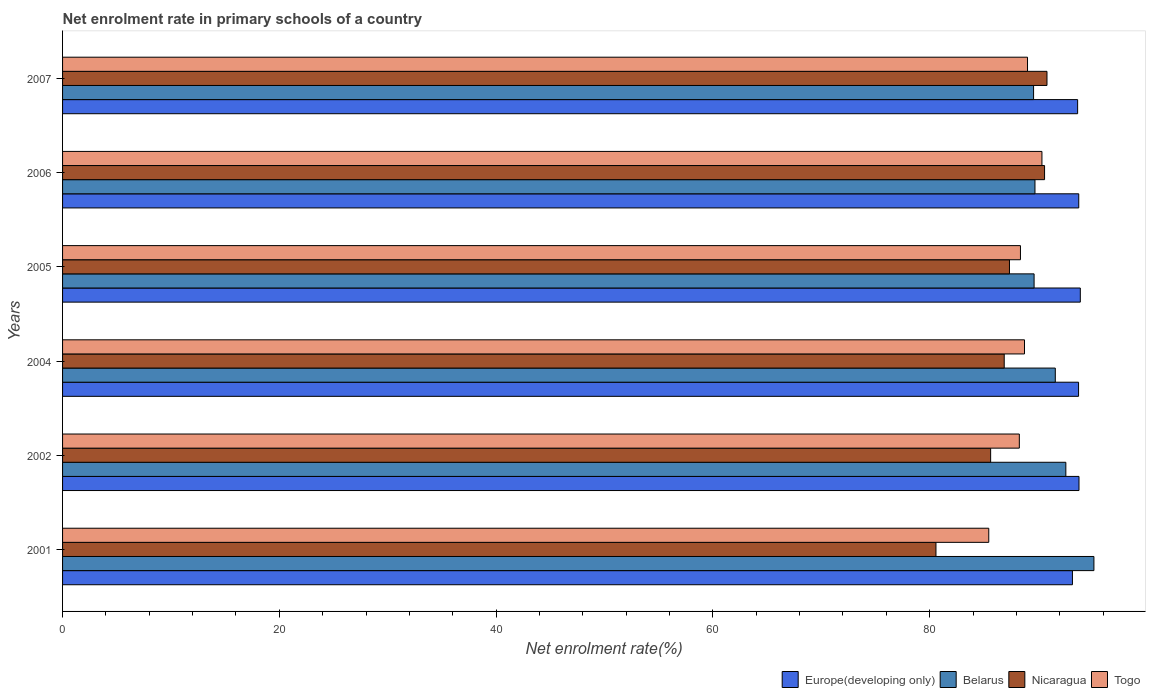How many different coloured bars are there?
Your answer should be very brief. 4. How many groups of bars are there?
Provide a succinct answer. 6. Are the number of bars on each tick of the Y-axis equal?
Your answer should be very brief. Yes. In how many cases, is the number of bars for a given year not equal to the number of legend labels?
Provide a short and direct response. 0. What is the net enrolment rate in primary schools in Belarus in 2005?
Offer a very short reply. 89.64. Across all years, what is the maximum net enrolment rate in primary schools in Belarus?
Provide a succinct answer. 95.16. Across all years, what is the minimum net enrolment rate in primary schools in Belarus?
Give a very brief answer. 89.59. In which year was the net enrolment rate in primary schools in Europe(developing only) maximum?
Offer a terse response. 2005. In which year was the net enrolment rate in primary schools in Togo minimum?
Your response must be concise. 2001. What is the total net enrolment rate in primary schools in Europe(developing only) in the graph?
Your answer should be very brief. 562.01. What is the difference between the net enrolment rate in primary schools in Nicaragua in 2002 and that in 2004?
Your answer should be very brief. -1.25. What is the difference between the net enrolment rate in primary schools in Togo in 2005 and the net enrolment rate in primary schools in Belarus in 2007?
Your answer should be very brief. -1.21. What is the average net enrolment rate in primary schools in Togo per year?
Make the answer very short. 88.38. In the year 2007, what is the difference between the net enrolment rate in primary schools in Europe(developing only) and net enrolment rate in primary schools in Belarus?
Provide a succinct answer. 4.06. What is the ratio of the net enrolment rate in primary schools in Nicaragua in 2005 to that in 2007?
Provide a succinct answer. 0.96. Is the difference between the net enrolment rate in primary schools in Europe(developing only) in 2004 and 2007 greater than the difference between the net enrolment rate in primary schools in Belarus in 2004 and 2007?
Keep it short and to the point. No. What is the difference between the highest and the second highest net enrolment rate in primary schools in Nicaragua?
Give a very brief answer. 0.22. What is the difference between the highest and the lowest net enrolment rate in primary schools in Europe(developing only)?
Ensure brevity in your answer.  0.73. What does the 4th bar from the top in 2001 represents?
Your answer should be compact. Europe(developing only). What does the 3rd bar from the bottom in 2005 represents?
Ensure brevity in your answer.  Nicaragua. What is the difference between two consecutive major ticks on the X-axis?
Give a very brief answer. 20. Does the graph contain any zero values?
Make the answer very short. No. What is the title of the graph?
Your response must be concise. Net enrolment rate in primary schools of a country. What is the label or title of the X-axis?
Offer a very short reply. Net enrolment rate(%). What is the Net enrolment rate(%) of Europe(developing only) in 2001?
Ensure brevity in your answer.  93.18. What is the Net enrolment rate(%) in Belarus in 2001?
Ensure brevity in your answer.  95.16. What is the Net enrolment rate(%) of Nicaragua in 2001?
Provide a short and direct response. 80.58. What is the Net enrolment rate(%) of Togo in 2001?
Your answer should be very brief. 85.45. What is the Net enrolment rate(%) in Europe(developing only) in 2002?
Offer a very short reply. 93.78. What is the Net enrolment rate(%) in Belarus in 2002?
Your answer should be compact. 92.57. What is the Net enrolment rate(%) in Nicaragua in 2002?
Your answer should be very brief. 85.63. What is the Net enrolment rate(%) of Togo in 2002?
Offer a very short reply. 88.28. What is the Net enrolment rate(%) in Europe(developing only) in 2004?
Make the answer very short. 93.74. What is the Net enrolment rate(%) of Belarus in 2004?
Keep it short and to the point. 91.59. What is the Net enrolment rate(%) in Nicaragua in 2004?
Give a very brief answer. 86.88. What is the Net enrolment rate(%) in Togo in 2004?
Offer a very short reply. 88.75. What is the Net enrolment rate(%) of Europe(developing only) in 2005?
Your answer should be compact. 93.9. What is the Net enrolment rate(%) of Belarus in 2005?
Offer a terse response. 89.64. What is the Net enrolment rate(%) of Nicaragua in 2005?
Keep it short and to the point. 87.37. What is the Net enrolment rate(%) in Togo in 2005?
Offer a very short reply. 88.38. What is the Net enrolment rate(%) of Europe(developing only) in 2006?
Your answer should be very brief. 93.76. What is the Net enrolment rate(%) in Belarus in 2006?
Provide a succinct answer. 89.72. What is the Net enrolment rate(%) in Nicaragua in 2006?
Offer a very short reply. 90.6. What is the Net enrolment rate(%) of Togo in 2006?
Ensure brevity in your answer.  90.36. What is the Net enrolment rate(%) in Europe(developing only) in 2007?
Offer a very short reply. 93.65. What is the Net enrolment rate(%) in Belarus in 2007?
Give a very brief answer. 89.59. What is the Net enrolment rate(%) in Nicaragua in 2007?
Ensure brevity in your answer.  90.83. What is the Net enrolment rate(%) in Togo in 2007?
Offer a terse response. 89.03. Across all years, what is the maximum Net enrolment rate(%) in Europe(developing only)?
Offer a terse response. 93.9. Across all years, what is the maximum Net enrolment rate(%) in Belarus?
Your answer should be very brief. 95.16. Across all years, what is the maximum Net enrolment rate(%) of Nicaragua?
Provide a succinct answer. 90.83. Across all years, what is the maximum Net enrolment rate(%) of Togo?
Provide a short and direct response. 90.36. Across all years, what is the minimum Net enrolment rate(%) of Europe(developing only)?
Make the answer very short. 93.18. Across all years, what is the minimum Net enrolment rate(%) of Belarus?
Your answer should be compact. 89.59. Across all years, what is the minimum Net enrolment rate(%) of Nicaragua?
Give a very brief answer. 80.58. Across all years, what is the minimum Net enrolment rate(%) in Togo?
Your answer should be compact. 85.45. What is the total Net enrolment rate(%) of Europe(developing only) in the graph?
Provide a succinct answer. 562.01. What is the total Net enrolment rate(%) of Belarus in the graph?
Give a very brief answer. 548.26. What is the total Net enrolment rate(%) of Nicaragua in the graph?
Your answer should be very brief. 521.89. What is the total Net enrolment rate(%) in Togo in the graph?
Offer a very short reply. 530.25. What is the difference between the Net enrolment rate(%) in Europe(developing only) in 2001 and that in 2002?
Offer a very short reply. -0.6. What is the difference between the Net enrolment rate(%) in Belarus in 2001 and that in 2002?
Give a very brief answer. 2.59. What is the difference between the Net enrolment rate(%) in Nicaragua in 2001 and that in 2002?
Make the answer very short. -5.04. What is the difference between the Net enrolment rate(%) in Togo in 2001 and that in 2002?
Offer a terse response. -2.82. What is the difference between the Net enrolment rate(%) in Europe(developing only) in 2001 and that in 2004?
Your response must be concise. -0.56. What is the difference between the Net enrolment rate(%) in Belarus in 2001 and that in 2004?
Keep it short and to the point. 3.56. What is the difference between the Net enrolment rate(%) in Nicaragua in 2001 and that in 2004?
Your answer should be compact. -6.3. What is the difference between the Net enrolment rate(%) in Togo in 2001 and that in 2004?
Provide a short and direct response. -3.3. What is the difference between the Net enrolment rate(%) of Europe(developing only) in 2001 and that in 2005?
Keep it short and to the point. -0.73. What is the difference between the Net enrolment rate(%) in Belarus in 2001 and that in 2005?
Your response must be concise. 5.52. What is the difference between the Net enrolment rate(%) in Nicaragua in 2001 and that in 2005?
Make the answer very short. -6.78. What is the difference between the Net enrolment rate(%) of Togo in 2001 and that in 2005?
Provide a short and direct response. -2.92. What is the difference between the Net enrolment rate(%) in Europe(developing only) in 2001 and that in 2006?
Your answer should be compact. -0.58. What is the difference between the Net enrolment rate(%) of Belarus in 2001 and that in 2006?
Your answer should be compact. 5.44. What is the difference between the Net enrolment rate(%) in Nicaragua in 2001 and that in 2006?
Offer a terse response. -10.02. What is the difference between the Net enrolment rate(%) of Togo in 2001 and that in 2006?
Offer a terse response. -4.91. What is the difference between the Net enrolment rate(%) in Europe(developing only) in 2001 and that in 2007?
Your response must be concise. -0.48. What is the difference between the Net enrolment rate(%) of Belarus in 2001 and that in 2007?
Provide a succinct answer. 5.57. What is the difference between the Net enrolment rate(%) of Nicaragua in 2001 and that in 2007?
Make the answer very short. -10.24. What is the difference between the Net enrolment rate(%) of Togo in 2001 and that in 2007?
Keep it short and to the point. -3.58. What is the difference between the Net enrolment rate(%) of Europe(developing only) in 2002 and that in 2004?
Your answer should be very brief. 0.04. What is the difference between the Net enrolment rate(%) in Belarus in 2002 and that in 2004?
Your answer should be compact. 0.97. What is the difference between the Net enrolment rate(%) in Nicaragua in 2002 and that in 2004?
Provide a short and direct response. -1.25. What is the difference between the Net enrolment rate(%) in Togo in 2002 and that in 2004?
Ensure brevity in your answer.  -0.48. What is the difference between the Net enrolment rate(%) in Europe(developing only) in 2002 and that in 2005?
Your answer should be very brief. -0.12. What is the difference between the Net enrolment rate(%) in Belarus in 2002 and that in 2005?
Keep it short and to the point. 2.93. What is the difference between the Net enrolment rate(%) in Nicaragua in 2002 and that in 2005?
Keep it short and to the point. -1.74. What is the difference between the Net enrolment rate(%) of Togo in 2002 and that in 2005?
Ensure brevity in your answer.  -0.1. What is the difference between the Net enrolment rate(%) in Europe(developing only) in 2002 and that in 2006?
Provide a succinct answer. 0.02. What is the difference between the Net enrolment rate(%) in Belarus in 2002 and that in 2006?
Provide a short and direct response. 2.85. What is the difference between the Net enrolment rate(%) of Nicaragua in 2002 and that in 2006?
Ensure brevity in your answer.  -4.98. What is the difference between the Net enrolment rate(%) of Togo in 2002 and that in 2006?
Make the answer very short. -2.08. What is the difference between the Net enrolment rate(%) in Europe(developing only) in 2002 and that in 2007?
Keep it short and to the point. 0.13. What is the difference between the Net enrolment rate(%) of Belarus in 2002 and that in 2007?
Provide a short and direct response. 2.98. What is the difference between the Net enrolment rate(%) of Nicaragua in 2002 and that in 2007?
Provide a short and direct response. -5.2. What is the difference between the Net enrolment rate(%) of Togo in 2002 and that in 2007?
Ensure brevity in your answer.  -0.76. What is the difference between the Net enrolment rate(%) of Europe(developing only) in 2004 and that in 2005?
Offer a very short reply. -0.16. What is the difference between the Net enrolment rate(%) in Belarus in 2004 and that in 2005?
Ensure brevity in your answer.  1.96. What is the difference between the Net enrolment rate(%) in Nicaragua in 2004 and that in 2005?
Your answer should be very brief. -0.48. What is the difference between the Net enrolment rate(%) in Togo in 2004 and that in 2005?
Provide a short and direct response. 0.37. What is the difference between the Net enrolment rate(%) of Europe(developing only) in 2004 and that in 2006?
Keep it short and to the point. -0.02. What is the difference between the Net enrolment rate(%) of Belarus in 2004 and that in 2006?
Your answer should be compact. 1.88. What is the difference between the Net enrolment rate(%) of Nicaragua in 2004 and that in 2006?
Ensure brevity in your answer.  -3.72. What is the difference between the Net enrolment rate(%) of Togo in 2004 and that in 2006?
Your answer should be very brief. -1.61. What is the difference between the Net enrolment rate(%) in Europe(developing only) in 2004 and that in 2007?
Offer a very short reply. 0.09. What is the difference between the Net enrolment rate(%) of Belarus in 2004 and that in 2007?
Keep it short and to the point. 2. What is the difference between the Net enrolment rate(%) in Nicaragua in 2004 and that in 2007?
Your answer should be very brief. -3.95. What is the difference between the Net enrolment rate(%) in Togo in 2004 and that in 2007?
Provide a succinct answer. -0.28. What is the difference between the Net enrolment rate(%) in Europe(developing only) in 2005 and that in 2006?
Provide a succinct answer. 0.15. What is the difference between the Net enrolment rate(%) of Belarus in 2005 and that in 2006?
Provide a succinct answer. -0.08. What is the difference between the Net enrolment rate(%) of Nicaragua in 2005 and that in 2006?
Make the answer very short. -3.24. What is the difference between the Net enrolment rate(%) of Togo in 2005 and that in 2006?
Your answer should be very brief. -1.98. What is the difference between the Net enrolment rate(%) of Europe(developing only) in 2005 and that in 2007?
Offer a terse response. 0.25. What is the difference between the Net enrolment rate(%) of Belarus in 2005 and that in 2007?
Your answer should be compact. 0.05. What is the difference between the Net enrolment rate(%) of Nicaragua in 2005 and that in 2007?
Your answer should be very brief. -3.46. What is the difference between the Net enrolment rate(%) in Togo in 2005 and that in 2007?
Make the answer very short. -0.65. What is the difference between the Net enrolment rate(%) of Europe(developing only) in 2006 and that in 2007?
Ensure brevity in your answer.  0.1. What is the difference between the Net enrolment rate(%) in Belarus in 2006 and that in 2007?
Give a very brief answer. 0.13. What is the difference between the Net enrolment rate(%) of Nicaragua in 2006 and that in 2007?
Your answer should be very brief. -0.22. What is the difference between the Net enrolment rate(%) in Togo in 2006 and that in 2007?
Ensure brevity in your answer.  1.33. What is the difference between the Net enrolment rate(%) of Europe(developing only) in 2001 and the Net enrolment rate(%) of Belarus in 2002?
Offer a very short reply. 0.61. What is the difference between the Net enrolment rate(%) in Europe(developing only) in 2001 and the Net enrolment rate(%) in Nicaragua in 2002?
Your answer should be compact. 7.55. What is the difference between the Net enrolment rate(%) of Europe(developing only) in 2001 and the Net enrolment rate(%) of Togo in 2002?
Offer a terse response. 4.9. What is the difference between the Net enrolment rate(%) in Belarus in 2001 and the Net enrolment rate(%) in Nicaragua in 2002?
Provide a succinct answer. 9.53. What is the difference between the Net enrolment rate(%) in Belarus in 2001 and the Net enrolment rate(%) in Togo in 2002?
Keep it short and to the point. 6.88. What is the difference between the Net enrolment rate(%) of Nicaragua in 2001 and the Net enrolment rate(%) of Togo in 2002?
Give a very brief answer. -7.69. What is the difference between the Net enrolment rate(%) in Europe(developing only) in 2001 and the Net enrolment rate(%) in Belarus in 2004?
Offer a very short reply. 1.58. What is the difference between the Net enrolment rate(%) in Europe(developing only) in 2001 and the Net enrolment rate(%) in Nicaragua in 2004?
Your answer should be very brief. 6.29. What is the difference between the Net enrolment rate(%) of Europe(developing only) in 2001 and the Net enrolment rate(%) of Togo in 2004?
Make the answer very short. 4.42. What is the difference between the Net enrolment rate(%) in Belarus in 2001 and the Net enrolment rate(%) in Nicaragua in 2004?
Keep it short and to the point. 8.28. What is the difference between the Net enrolment rate(%) of Belarus in 2001 and the Net enrolment rate(%) of Togo in 2004?
Your answer should be compact. 6.41. What is the difference between the Net enrolment rate(%) in Nicaragua in 2001 and the Net enrolment rate(%) in Togo in 2004?
Offer a terse response. -8.17. What is the difference between the Net enrolment rate(%) in Europe(developing only) in 2001 and the Net enrolment rate(%) in Belarus in 2005?
Give a very brief answer. 3.54. What is the difference between the Net enrolment rate(%) in Europe(developing only) in 2001 and the Net enrolment rate(%) in Nicaragua in 2005?
Offer a very short reply. 5.81. What is the difference between the Net enrolment rate(%) in Europe(developing only) in 2001 and the Net enrolment rate(%) in Togo in 2005?
Offer a very short reply. 4.8. What is the difference between the Net enrolment rate(%) of Belarus in 2001 and the Net enrolment rate(%) of Nicaragua in 2005?
Give a very brief answer. 7.79. What is the difference between the Net enrolment rate(%) of Belarus in 2001 and the Net enrolment rate(%) of Togo in 2005?
Ensure brevity in your answer.  6.78. What is the difference between the Net enrolment rate(%) in Nicaragua in 2001 and the Net enrolment rate(%) in Togo in 2005?
Keep it short and to the point. -7.79. What is the difference between the Net enrolment rate(%) of Europe(developing only) in 2001 and the Net enrolment rate(%) of Belarus in 2006?
Provide a short and direct response. 3.46. What is the difference between the Net enrolment rate(%) in Europe(developing only) in 2001 and the Net enrolment rate(%) in Nicaragua in 2006?
Make the answer very short. 2.57. What is the difference between the Net enrolment rate(%) of Europe(developing only) in 2001 and the Net enrolment rate(%) of Togo in 2006?
Offer a very short reply. 2.82. What is the difference between the Net enrolment rate(%) of Belarus in 2001 and the Net enrolment rate(%) of Nicaragua in 2006?
Make the answer very short. 4.55. What is the difference between the Net enrolment rate(%) of Belarus in 2001 and the Net enrolment rate(%) of Togo in 2006?
Provide a short and direct response. 4.8. What is the difference between the Net enrolment rate(%) of Nicaragua in 2001 and the Net enrolment rate(%) of Togo in 2006?
Your answer should be compact. -9.78. What is the difference between the Net enrolment rate(%) in Europe(developing only) in 2001 and the Net enrolment rate(%) in Belarus in 2007?
Your answer should be very brief. 3.59. What is the difference between the Net enrolment rate(%) of Europe(developing only) in 2001 and the Net enrolment rate(%) of Nicaragua in 2007?
Your answer should be very brief. 2.35. What is the difference between the Net enrolment rate(%) of Europe(developing only) in 2001 and the Net enrolment rate(%) of Togo in 2007?
Offer a terse response. 4.14. What is the difference between the Net enrolment rate(%) in Belarus in 2001 and the Net enrolment rate(%) in Nicaragua in 2007?
Make the answer very short. 4.33. What is the difference between the Net enrolment rate(%) in Belarus in 2001 and the Net enrolment rate(%) in Togo in 2007?
Make the answer very short. 6.13. What is the difference between the Net enrolment rate(%) in Nicaragua in 2001 and the Net enrolment rate(%) in Togo in 2007?
Your answer should be very brief. -8.45. What is the difference between the Net enrolment rate(%) of Europe(developing only) in 2002 and the Net enrolment rate(%) of Belarus in 2004?
Your response must be concise. 2.19. What is the difference between the Net enrolment rate(%) of Europe(developing only) in 2002 and the Net enrolment rate(%) of Nicaragua in 2004?
Your response must be concise. 6.9. What is the difference between the Net enrolment rate(%) of Europe(developing only) in 2002 and the Net enrolment rate(%) of Togo in 2004?
Your answer should be compact. 5.03. What is the difference between the Net enrolment rate(%) of Belarus in 2002 and the Net enrolment rate(%) of Nicaragua in 2004?
Your response must be concise. 5.69. What is the difference between the Net enrolment rate(%) of Belarus in 2002 and the Net enrolment rate(%) of Togo in 2004?
Your response must be concise. 3.82. What is the difference between the Net enrolment rate(%) in Nicaragua in 2002 and the Net enrolment rate(%) in Togo in 2004?
Ensure brevity in your answer.  -3.12. What is the difference between the Net enrolment rate(%) of Europe(developing only) in 2002 and the Net enrolment rate(%) of Belarus in 2005?
Make the answer very short. 4.14. What is the difference between the Net enrolment rate(%) in Europe(developing only) in 2002 and the Net enrolment rate(%) in Nicaragua in 2005?
Your answer should be very brief. 6.41. What is the difference between the Net enrolment rate(%) of Europe(developing only) in 2002 and the Net enrolment rate(%) of Togo in 2005?
Your answer should be very brief. 5.4. What is the difference between the Net enrolment rate(%) of Belarus in 2002 and the Net enrolment rate(%) of Nicaragua in 2005?
Your answer should be compact. 5.2. What is the difference between the Net enrolment rate(%) of Belarus in 2002 and the Net enrolment rate(%) of Togo in 2005?
Ensure brevity in your answer.  4.19. What is the difference between the Net enrolment rate(%) in Nicaragua in 2002 and the Net enrolment rate(%) in Togo in 2005?
Provide a succinct answer. -2.75. What is the difference between the Net enrolment rate(%) in Europe(developing only) in 2002 and the Net enrolment rate(%) in Belarus in 2006?
Your response must be concise. 4.06. What is the difference between the Net enrolment rate(%) in Europe(developing only) in 2002 and the Net enrolment rate(%) in Nicaragua in 2006?
Offer a terse response. 3.18. What is the difference between the Net enrolment rate(%) in Europe(developing only) in 2002 and the Net enrolment rate(%) in Togo in 2006?
Offer a terse response. 3.42. What is the difference between the Net enrolment rate(%) in Belarus in 2002 and the Net enrolment rate(%) in Nicaragua in 2006?
Provide a succinct answer. 1.96. What is the difference between the Net enrolment rate(%) in Belarus in 2002 and the Net enrolment rate(%) in Togo in 2006?
Offer a terse response. 2.21. What is the difference between the Net enrolment rate(%) in Nicaragua in 2002 and the Net enrolment rate(%) in Togo in 2006?
Offer a very short reply. -4.73. What is the difference between the Net enrolment rate(%) in Europe(developing only) in 2002 and the Net enrolment rate(%) in Belarus in 2007?
Give a very brief answer. 4.19. What is the difference between the Net enrolment rate(%) in Europe(developing only) in 2002 and the Net enrolment rate(%) in Nicaragua in 2007?
Your answer should be compact. 2.95. What is the difference between the Net enrolment rate(%) in Europe(developing only) in 2002 and the Net enrolment rate(%) in Togo in 2007?
Offer a terse response. 4.75. What is the difference between the Net enrolment rate(%) of Belarus in 2002 and the Net enrolment rate(%) of Nicaragua in 2007?
Ensure brevity in your answer.  1.74. What is the difference between the Net enrolment rate(%) in Belarus in 2002 and the Net enrolment rate(%) in Togo in 2007?
Your answer should be very brief. 3.54. What is the difference between the Net enrolment rate(%) in Nicaragua in 2002 and the Net enrolment rate(%) in Togo in 2007?
Make the answer very short. -3.4. What is the difference between the Net enrolment rate(%) in Europe(developing only) in 2004 and the Net enrolment rate(%) in Belarus in 2005?
Provide a short and direct response. 4.1. What is the difference between the Net enrolment rate(%) of Europe(developing only) in 2004 and the Net enrolment rate(%) of Nicaragua in 2005?
Offer a very short reply. 6.37. What is the difference between the Net enrolment rate(%) of Europe(developing only) in 2004 and the Net enrolment rate(%) of Togo in 2005?
Give a very brief answer. 5.36. What is the difference between the Net enrolment rate(%) of Belarus in 2004 and the Net enrolment rate(%) of Nicaragua in 2005?
Offer a terse response. 4.23. What is the difference between the Net enrolment rate(%) of Belarus in 2004 and the Net enrolment rate(%) of Togo in 2005?
Offer a terse response. 3.21. What is the difference between the Net enrolment rate(%) in Nicaragua in 2004 and the Net enrolment rate(%) in Togo in 2005?
Provide a short and direct response. -1.5. What is the difference between the Net enrolment rate(%) in Europe(developing only) in 2004 and the Net enrolment rate(%) in Belarus in 2006?
Your answer should be compact. 4.02. What is the difference between the Net enrolment rate(%) in Europe(developing only) in 2004 and the Net enrolment rate(%) in Nicaragua in 2006?
Ensure brevity in your answer.  3.14. What is the difference between the Net enrolment rate(%) in Europe(developing only) in 2004 and the Net enrolment rate(%) in Togo in 2006?
Your answer should be very brief. 3.38. What is the difference between the Net enrolment rate(%) of Belarus in 2004 and the Net enrolment rate(%) of Togo in 2006?
Make the answer very short. 1.23. What is the difference between the Net enrolment rate(%) of Nicaragua in 2004 and the Net enrolment rate(%) of Togo in 2006?
Keep it short and to the point. -3.48. What is the difference between the Net enrolment rate(%) in Europe(developing only) in 2004 and the Net enrolment rate(%) in Belarus in 2007?
Provide a succinct answer. 4.15. What is the difference between the Net enrolment rate(%) in Europe(developing only) in 2004 and the Net enrolment rate(%) in Nicaragua in 2007?
Your response must be concise. 2.91. What is the difference between the Net enrolment rate(%) in Europe(developing only) in 2004 and the Net enrolment rate(%) in Togo in 2007?
Offer a terse response. 4.71. What is the difference between the Net enrolment rate(%) in Belarus in 2004 and the Net enrolment rate(%) in Nicaragua in 2007?
Offer a very short reply. 0.77. What is the difference between the Net enrolment rate(%) in Belarus in 2004 and the Net enrolment rate(%) in Togo in 2007?
Give a very brief answer. 2.56. What is the difference between the Net enrolment rate(%) in Nicaragua in 2004 and the Net enrolment rate(%) in Togo in 2007?
Ensure brevity in your answer.  -2.15. What is the difference between the Net enrolment rate(%) of Europe(developing only) in 2005 and the Net enrolment rate(%) of Belarus in 2006?
Ensure brevity in your answer.  4.18. What is the difference between the Net enrolment rate(%) of Europe(developing only) in 2005 and the Net enrolment rate(%) of Nicaragua in 2006?
Give a very brief answer. 3.3. What is the difference between the Net enrolment rate(%) in Europe(developing only) in 2005 and the Net enrolment rate(%) in Togo in 2006?
Provide a succinct answer. 3.54. What is the difference between the Net enrolment rate(%) in Belarus in 2005 and the Net enrolment rate(%) in Nicaragua in 2006?
Offer a very short reply. -0.97. What is the difference between the Net enrolment rate(%) in Belarus in 2005 and the Net enrolment rate(%) in Togo in 2006?
Give a very brief answer. -0.72. What is the difference between the Net enrolment rate(%) of Nicaragua in 2005 and the Net enrolment rate(%) of Togo in 2006?
Offer a terse response. -2.99. What is the difference between the Net enrolment rate(%) of Europe(developing only) in 2005 and the Net enrolment rate(%) of Belarus in 2007?
Make the answer very short. 4.31. What is the difference between the Net enrolment rate(%) of Europe(developing only) in 2005 and the Net enrolment rate(%) of Nicaragua in 2007?
Your answer should be very brief. 3.08. What is the difference between the Net enrolment rate(%) in Europe(developing only) in 2005 and the Net enrolment rate(%) in Togo in 2007?
Your answer should be compact. 4.87. What is the difference between the Net enrolment rate(%) of Belarus in 2005 and the Net enrolment rate(%) of Nicaragua in 2007?
Your response must be concise. -1.19. What is the difference between the Net enrolment rate(%) of Belarus in 2005 and the Net enrolment rate(%) of Togo in 2007?
Ensure brevity in your answer.  0.61. What is the difference between the Net enrolment rate(%) of Nicaragua in 2005 and the Net enrolment rate(%) of Togo in 2007?
Give a very brief answer. -1.67. What is the difference between the Net enrolment rate(%) in Europe(developing only) in 2006 and the Net enrolment rate(%) in Belarus in 2007?
Give a very brief answer. 4.17. What is the difference between the Net enrolment rate(%) in Europe(developing only) in 2006 and the Net enrolment rate(%) in Nicaragua in 2007?
Keep it short and to the point. 2.93. What is the difference between the Net enrolment rate(%) in Europe(developing only) in 2006 and the Net enrolment rate(%) in Togo in 2007?
Make the answer very short. 4.73. What is the difference between the Net enrolment rate(%) of Belarus in 2006 and the Net enrolment rate(%) of Nicaragua in 2007?
Ensure brevity in your answer.  -1.11. What is the difference between the Net enrolment rate(%) in Belarus in 2006 and the Net enrolment rate(%) in Togo in 2007?
Your answer should be very brief. 0.69. What is the difference between the Net enrolment rate(%) in Nicaragua in 2006 and the Net enrolment rate(%) in Togo in 2007?
Offer a very short reply. 1.57. What is the average Net enrolment rate(%) in Europe(developing only) per year?
Your response must be concise. 93.67. What is the average Net enrolment rate(%) in Belarus per year?
Keep it short and to the point. 91.38. What is the average Net enrolment rate(%) of Nicaragua per year?
Your answer should be very brief. 86.98. What is the average Net enrolment rate(%) of Togo per year?
Ensure brevity in your answer.  88.38. In the year 2001, what is the difference between the Net enrolment rate(%) of Europe(developing only) and Net enrolment rate(%) of Belarus?
Provide a short and direct response. -1.98. In the year 2001, what is the difference between the Net enrolment rate(%) in Europe(developing only) and Net enrolment rate(%) in Nicaragua?
Make the answer very short. 12.59. In the year 2001, what is the difference between the Net enrolment rate(%) in Europe(developing only) and Net enrolment rate(%) in Togo?
Provide a succinct answer. 7.72. In the year 2001, what is the difference between the Net enrolment rate(%) in Belarus and Net enrolment rate(%) in Nicaragua?
Offer a terse response. 14.57. In the year 2001, what is the difference between the Net enrolment rate(%) of Belarus and Net enrolment rate(%) of Togo?
Keep it short and to the point. 9.7. In the year 2001, what is the difference between the Net enrolment rate(%) in Nicaragua and Net enrolment rate(%) in Togo?
Your answer should be compact. -4.87. In the year 2002, what is the difference between the Net enrolment rate(%) in Europe(developing only) and Net enrolment rate(%) in Belarus?
Give a very brief answer. 1.21. In the year 2002, what is the difference between the Net enrolment rate(%) of Europe(developing only) and Net enrolment rate(%) of Nicaragua?
Give a very brief answer. 8.15. In the year 2002, what is the difference between the Net enrolment rate(%) of Europe(developing only) and Net enrolment rate(%) of Togo?
Your response must be concise. 5.5. In the year 2002, what is the difference between the Net enrolment rate(%) in Belarus and Net enrolment rate(%) in Nicaragua?
Give a very brief answer. 6.94. In the year 2002, what is the difference between the Net enrolment rate(%) of Belarus and Net enrolment rate(%) of Togo?
Your answer should be compact. 4.29. In the year 2002, what is the difference between the Net enrolment rate(%) in Nicaragua and Net enrolment rate(%) in Togo?
Your answer should be very brief. -2.65. In the year 2004, what is the difference between the Net enrolment rate(%) of Europe(developing only) and Net enrolment rate(%) of Belarus?
Ensure brevity in your answer.  2.15. In the year 2004, what is the difference between the Net enrolment rate(%) of Europe(developing only) and Net enrolment rate(%) of Nicaragua?
Ensure brevity in your answer.  6.86. In the year 2004, what is the difference between the Net enrolment rate(%) of Europe(developing only) and Net enrolment rate(%) of Togo?
Ensure brevity in your answer.  4.99. In the year 2004, what is the difference between the Net enrolment rate(%) in Belarus and Net enrolment rate(%) in Nicaragua?
Provide a short and direct response. 4.71. In the year 2004, what is the difference between the Net enrolment rate(%) in Belarus and Net enrolment rate(%) in Togo?
Your answer should be compact. 2.84. In the year 2004, what is the difference between the Net enrolment rate(%) of Nicaragua and Net enrolment rate(%) of Togo?
Provide a short and direct response. -1.87. In the year 2005, what is the difference between the Net enrolment rate(%) in Europe(developing only) and Net enrolment rate(%) in Belarus?
Provide a succinct answer. 4.26. In the year 2005, what is the difference between the Net enrolment rate(%) of Europe(developing only) and Net enrolment rate(%) of Nicaragua?
Make the answer very short. 6.54. In the year 2005, what is the difference between the Net enrolment rate(%) in Europe(developing only) and Net enrolment rate(%) in Togo?
Provide a short and direct response. 5.52. In the year 2005, what is the difference between the Net enrolment rate(%) of Belarus and Net enrolment rate(%) of Nicaragua?
Keep it short and to the point. 2.27. In the year 2005, what is the difference between the Net enrolment rate(%) in Belarus and Net enrolment rate(%) in Togo?
Ensure brevity in your answer.  1.26. In the year 2005, what is the difference between the Net enrolment rate(%) in Nicaragua and Net enrolment rate(%) in Togo?
Offer a very short reply. -1.01. In the year 2006, what is the difference between the Net enrolment rate(%) in Europe(developing only) and Net enrolment rate(%) in Belarus?
Offer a very short reply. 4.04. In the year 2006, what is the difference between the Net enrolment rate(%) of Europe(developing only) and Net enrolment rate(%) of Nicaragua?
Provide a succinct answer. 3.15. In the year 2006, what is the difference between the Net enrolment rate(%) in Europe(developing only) and Net enrolment rate(%) in Togo?
Make the answer very short. 3.4. In the year 2006, what is the difference between the Net enrolment rate(%) in Belarus and Net enrolment rate(%) in Nicaragua?
Ensure brevity in your answer.  -0.89. In the year 2006, what is the difference between the Net enrolment rate(%) of Belarus and Net enrolment rate(%) of Togo?
Provide a short and direct response. -0.64. In the year 2006, what is the difference between the Net enrolment rate(%) of Nicaragua and Net enrolment rate(%) of Togo?
Offer a terse response. 0.24. In the year 2007, what is the difference between the Net enrolment rate(%) in Europe(developing only) and Net enrolment rate(%) in Belarus?
Provide a short and direct response. 4.06. In the year 2007, what is the difference between the Net enrolment rate(%) of Europe(developing only) and Net enrolment rate(%) of Nicaragua?
Offer a very short reply. 2.83. In the year 2007, what is the difference between the Net enrolment rate(%) of Europe(developing only) and Net enrolment rate(%) of Togo?
Offer a terse response. 4.62. In the year 2007, what is the difference between the Net enrolment rate(%) in Belarus and Net enrolment rate(%) in Nicaragua?
Offer a terse response. -1.24. In the year 2007, what is the difference between the Net enrolment rate(%) in Belarus and Net enrolment rate(%) in Togo?
Your response must be concise. 0.56. In the year 2007, what is the difference between the Net enrolment rate(%) in Nicaragua and Net enrolment rate(%) in Togo?
Make the answer very short. 1.8. What is the ratio of the Net enrolment rate(%) of Belarus in 2001 to that in 2002?
Provide a succinct answer. 1.03. What is the ratio of the Net enrolment rate(%) of Nicaragua in 2001 to that in 2002?
Ensure brevity in your answer.  0.94. What is the ratio of the Net enrolment rate(%) in Togo in 2001 to that in 2002?
Ensure brevity in your answer.  0.97. What is the ratio of the Net enrolment rate(%) in Belarus in 2001 to that in 2004?
Make the answer very short. 1.04. What is the ratio of the Net enrolment rate(%) of Nicaragua in 2001 to that in 2004?
Your answer should be very brief. 0.93. What is the ratio of the Net enrolment rate(%) in Togo in 2001 to that in 2004?
Provide a succinct answer. 0.96. What is the ratio of the Net enrolment rate(%) in Belarus in 2001 to that in 2005?
Keep it short and to the point. 1.06. What is the ratio of the Net enrolment rate(%) in Nicaragua in 2001 to that in 2005?
Make the answer very short. 0.92. What is the ratio of the Net enrolment rate(%) in Togo in 2001 to that in 2005?
Your answer should be compact. 0.97. What is the ratio of the Net enrolment rate(%) in Europe(developing only) in 2001 to that in 2006?
Ensure brevity in your answer.  0.99. What is the ratio of the Net enrolment rate(%) in Belarus in 2001 to that in 2006?
Your response must be concise. 1.06. What is the ratio of the Net enrolment rate(%) of Nicaragua in 2001 to that in 2006?
Keep it short and to the point. 0.89. What is the ratio of the Net enrolment rate(%) of Togo in 2001 to that in 2006?
Your response must be concise. 0.95. What is the ratio of the Net enrolment rate(%) of Belarus in 2001 to that in 2007?
Provide a short and direct response. 1.06. What is the ratio of the Net enrolment rate(%) of Nicaragua in 2001 to that in 2007?
Your answer should be compact. 0.89. What is the ratio of the Net enrolment rate(%) of Togo in 2001 to that in 2007?
Offer a terse response. 0.96. What is the ratio of the Net enrolment rate(%) of Belarus in 2002 to that in 2004?
Your answer should be very brief. 1.01. What is the ratio of the Net enrolment rate(%) in Nicaragua in 2002 to that in 2004?
Give a very brief answer. 0.99. What is the ratio of the Net enrolment rate(%) in Europe(developing only) in 2002 to that in 2005?
Provide a short and direct response. 1. What is the ratio of the Net enrolment rate(%) in Belarus in 2002 to that in 2005?
Ensure brevity in your answer.  1.03. What is the ratio of the Net enrolment rate(%) in Nicaragua in 2002 to that in 2005?
Make the answer very short. 0.98. What is the ratio of the Net enrolment rate(%) of Togo in 2002 to that in 2005?
Give a very brief answer. 1. What is the ratio of the Net enrolment rate(%) of Belarus in 2002 to that in 2006?
Your answer should be very brief. 1.03. What is the ratio of the Net enrolment rate(%) in Nicaragua in 2002 to that in 2006?
Your answer should be compact. 0.95. What is the ratio of the Net enrolment rate(%) in Togo in 2002 to that in 2006?
Keep it short and to the point. 0.98. What is the ratio of the Net enrolment rate(%) in Belarus in 2002 to that in 2007?
Your answer should be compact. 1.03. What is the ratio of the Net enrolment rate(%) of Nicaragua in 2002 to that in 2007?
Keep it short and to the point. 0.94. What is the ratio of the Net enrolment rate(%) in Europe(developing only) in 2004 to that in 2005?
Make the answer very short. 1. What is the ratio of the Net enrolment rate(%) of Belarus in 2004 to that in 2005?
Provide a short and direct response. 1.02. What is the ratio of the Net enrolment rate(%) of Togo in 2004 to that in 2005?
Ensure brevity in your answer.  1. What is the ratio of the Net enrolment rate(%) of Belarus in 2004 to that in 2006?
Your answer should be very brief. 1.02. What is the ratio of the Net enrolment rate(%) of Nicaragua in 2004 to that in 2006?
Provide a short and direct response. 0.96. What is the ratio of the Net enrolment rate(%) in Togo in 2004 to that in 2006?
Keep it short and to the point. 0.98. What is the ratio of the Net enrolment rate(%) in Belarus in 2004 to that in 2007?
Your response must be concise. 1.02. What is the ratio of the Net enrolment rate(%) in Nicaragua in 2004 to that in 2007?
Offer a very short reply. 0.96. What is the ratio of the Net enrolment rate(%) in Togo in 2004 to that in 2007?
Give a very brief answer. 1. What is the ratio of the Net enrolment rate(%) of Nicaragua in 2005 to that in 2006?
Your answer should be compact. 0.96. What is the ratio of the Net enrolment rate(%) of Togo in 2005 to that in 2006?
Make the answer very short. 0.98. What is the ratio of the Net enrolment rate(%) of Nicaragua in 2005 to that in 2007?
Make the answer very short. 0.96. What is the ratio of the Net enrolment rate(%) in Togo in 2006 to that in 2007?
Ensure brevity in your answer.  1.01. What is the difference between the highest and the second highest Net enrolment rate(%) in Europe(developing only)?
Give a very brief answer. 0.12. What is the difference between the highest and the second highest Net enrolment rate(%) in Belarus?
Keep it short and to the point. 2.59. What is the difference between the highest and the second highest Net enrolment rate(%) of Nicaragua?
Your answer should be very brief. 0.22. What is the difference between the highest and the second highest Net enrolment rate(%) of Togo?
Make the answer very short. 1.33. What is the difference between the highest and the lowest Net enrolment rate(%) of Europe(developing only)?
Provide a short and direct response. 0.73. What is the difference between the highest and the lowest Net enrolment rate(%) in Belarus?
Give a very brief answer. 5.57. What is the difference between the highest and the lowest Net enrolment rate(%) in Nicaragua?
Keep it short and to the point. 10.24. What is the difference between the highest and the lowest Net enrolment rate(%) in Togo?
Keep it short and to the point. 4.91. 